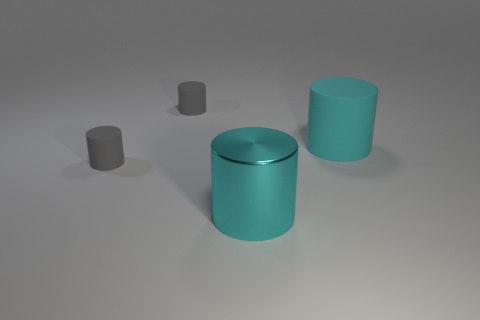Subtract all gray cylinders. How many cylinders are left? 2 Subtract all large metal cylinders. How many cylinders are left? 3 Subtract 0 green cubes. How many objects are left? 4 Subtract 2 cylinders. How many cylinders are left? 2 Subtract all gray cylinders. Subtract all purple cubes. How many cylinders are left? 2 Subtract all gray balls. How many gray cylinders are left? 2 Subtract all metallic objects. Subtract all large cylinders. How many objects are left? 1 Add 3 cyan shiny cylinders. How many cyan shiny cylinders are left? 4 Add 1 tiny red things. How many tiny red things exist? 1 Add 3 purple metallic objects. How many objects exist? 7 